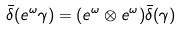<formula> <loc_0><loc_0><loc_500><loc_500>\bar { \delta } ( e ^ { \omega } \gamma ) = ( e ^ { \omega } \otimes e ^ { \omega } ) \bar { \delta } ( \gamma )</formula> 